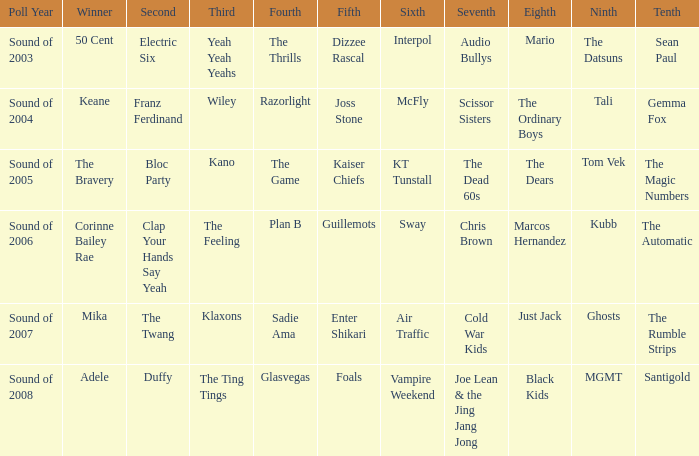Who was in 4th when in 6th is Air Traffic? Sadie Ama. Parse the table in full. {'header': ['Poll Year', 'Winner', 'Second', 'Third', 'Fourth', 'Fifth', 'Sixth', 'Seventh', 'Eighth', 'Ninth', 'Tenth'], 'rows': [['Sound of 2003', '50 Cent', 'Electric Six', 'Yeah Yeah Yeahs', 'The Thrills', 'Dizzee Rascal', 'Interpol', 'Audio Bullys', 'Mario', 'The Datsuns', 'Sean Paul'], ['Sound of 2004', 'Keane', 'Franz Ferdinand', 'Wiley', 'Razorlight', 'Joss Stone', 'McFly', 'Scissor Sisters', 'The Ordinary Boys', 'Tali', 'Gemma Fox'], ['Sound of 2005', 'The Bravery', 'Bloc Party', 'Kano', 'The Game', 'Kaiser Chiefs', 'KT Tunstall', 'The Dead 60s', 'The Dears', 'Tom Vek', 'The Magic Numbers'], ['Sound of 2006', 'Corinne Bailey Rae', 'Clap Your Hands Say Yeah', 'The Feeling', 'Plan B', 'Guillemots', 'Sway', 'Chris Brown', 'Marcos Hernandez', 'Kubb', 'The Automatic'], ['Sound of 2007', 'Mika', 'The Twang', 'Klaxons', 'Sadie Ama', 'Enter Shikari', 'Air Traffic', 'Cold War Kids', 'Just Jack', 'Ghosts', 'The Rumble Strips'], ['Sound of 2008', 'Adele', 'Duffy', 'The Ting Tings', 'Glasvegas', 'Foals', 'Vampire Weekend', 'Joe Lean & the Jing Jang Jong', 'Black Kids', 'MGMT', 'Santigold']]} 